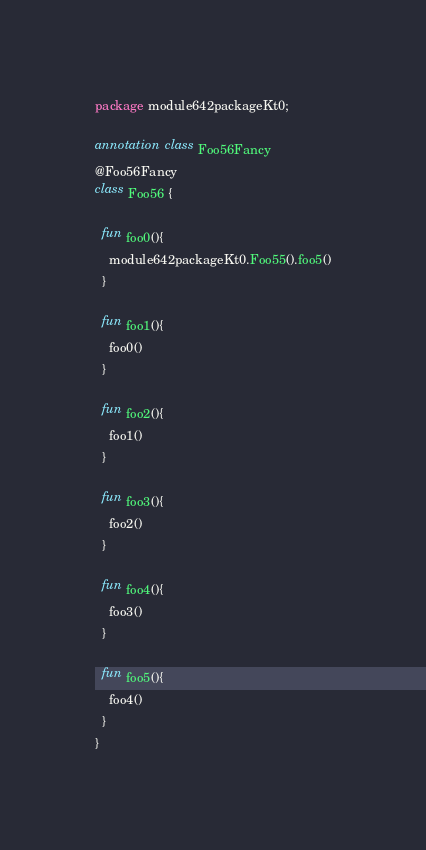Convert code to text. <code><loc_0><loc_0><loc_500><loc_500><_Kotlin_>package module642packageKt0;

annotation class Foo56Fancy
@Foo56Fancy
class Foo56 {

  fun foo0(){
    module642packageKt0.Foo55().foo5()
  }

  fun foo1(){
    foo0()
  }

  fun foo2(){
    foo1()
  }

  fun foo3(){
    foo2()
  }

  fun foo4(){
    foo3()
  }

  fun foo5(){
    foo4()
  }
}</code> 